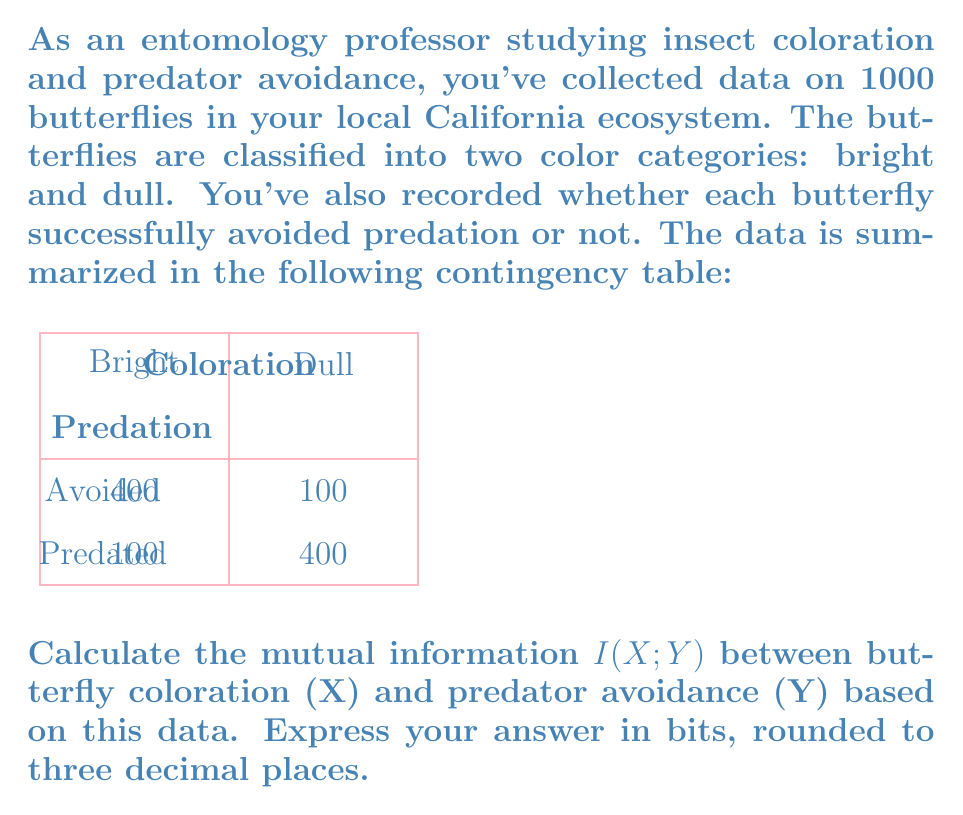Teach me how to tackle this problem. Let's approach this step-by-step:

1) First, we need to calculate the probabilities:

   $P(X = \text{Bright}) = 500/1000 = 0.5$
   $P(X = \text{Dull}) = 500/1000 = 0.5$
   $P(Y = \text{Avoided}) = 500/1000 = 0.5$
   $P(Y = \text{Predated}) = 500/1000 = 0.5$

   $P(X = \text{Bright}, Y = \text{Avoided}) = 400/1000 = 0.4$
   $P(X = \text{Bright}, Y = \text{Predated}) = 100/1000 = 0.1$
   $P(X = \text{Dull}, Y = \text{Avoided}) = 100/1000 = 0.1$
   $P(X = \text{Dull}, Y = \text{Predated}) = 400/1000 = 0.4$

2) The mutual information is defined as:

   $$I(X;Y) = \sum_{x \in X} \sum_{y \in Y} P(x,y) \log_2 \left(\frac{P(x,y)}{P(x)P(y)}\right)$$

3) Let's calculate each term:

   $0.4 \log_2 (0.4 / (0.5 * 0.5)) = 0.4 \log_2 1.6 = 0.2630$
   $0.1 \log_2 (0.1 / (0.5 * 0.5)) = 0.1 \log_2 0.4 = -0.1515$
   $0.1 \log_2 (0.1 / (0.5 * 0.5)) = 0.1 \log_2 0.4 = -0.1515$
   $0.4 \log_2 (0.4 / (0.5 * 0.5)) = 0.4 \log_2 1.6 = 0.2630$

4) Sum all these terms:

   $I(X;Y) = 0.2630 - 0.1515 - 0.1515 + 0.2630 = 0.2230$ bits

5) Rounding to three decimal places:

   $I(X;Y) \approx 0.223$ bits
Answer: 0.223 bits 